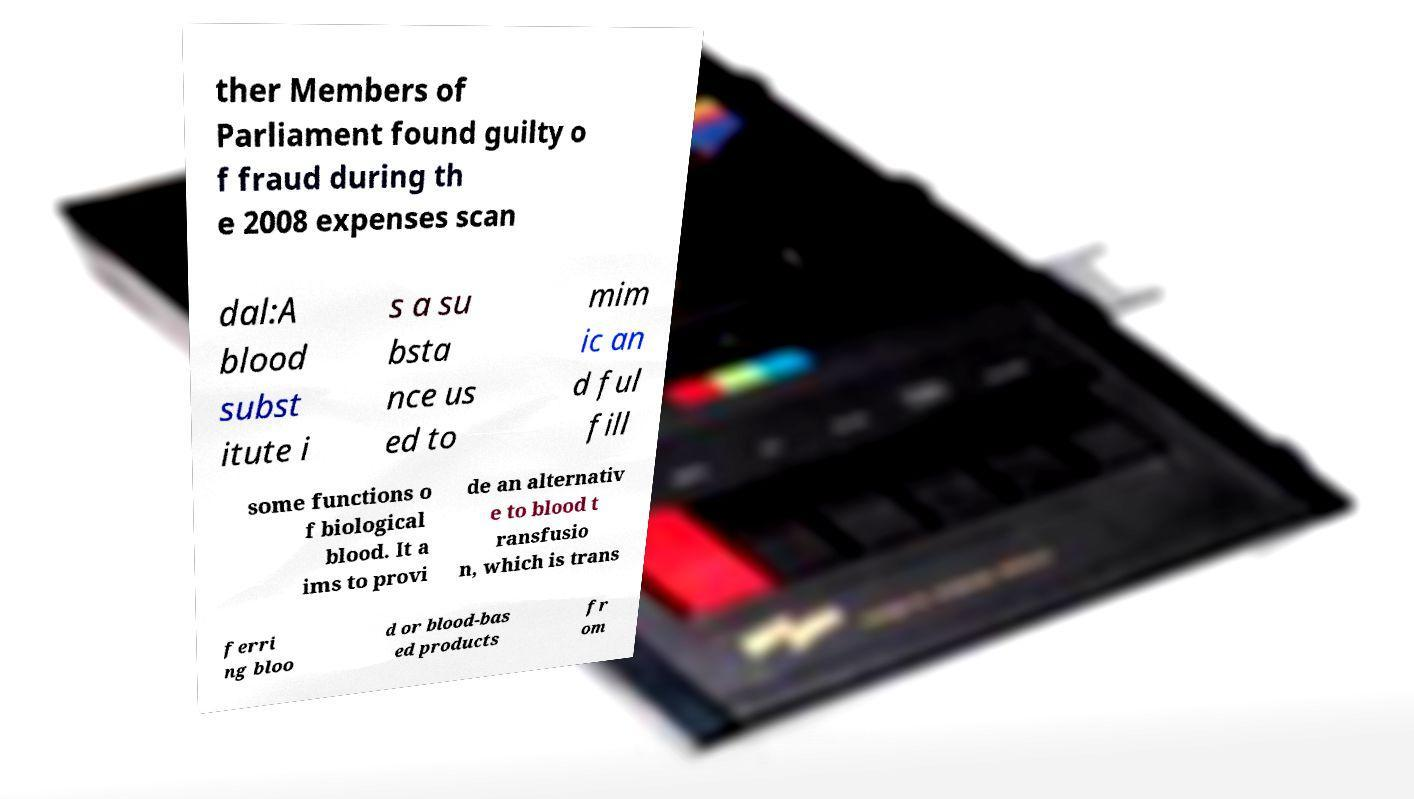Could you assist in decoding the text presented in this image and type it out clearly? ther Members of Parliament found guilty o f fraud during th e 2008 expenses scan dal:A blood subst itute i s a su bsta nce us ed to mim ic an d ful fill some functions o f biological blood. It a ims to provi de an alternativ e to blood t ransfusio n, which is trans ferri ng bloo d or blood-bas ed products fr om 